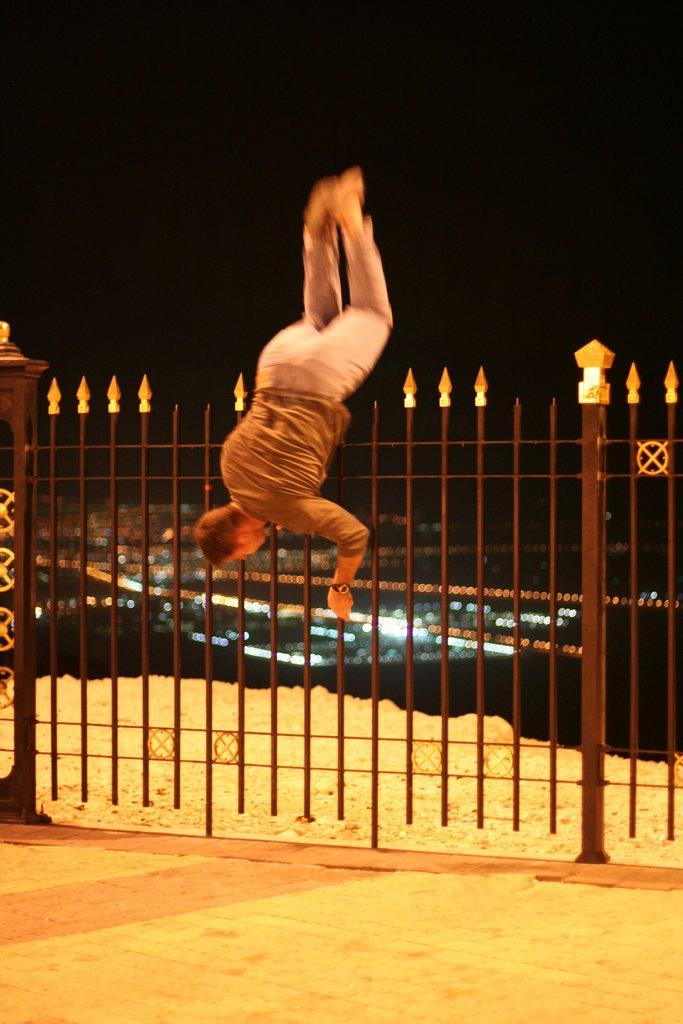What is in the foreground of the image? There is sand in the foreground of the image. What can be seen in the middle of the image? Iron rods are present in the middle of the image, and a man is doing stunts there. What is the condition of the top part of the image? The top of the image appears to be dark. What type of selection process is being conducted by the sand in the foreground of the image? The sand in the foreground of the image is not conducting any selection process; it is simply a natural substance present in the image. 